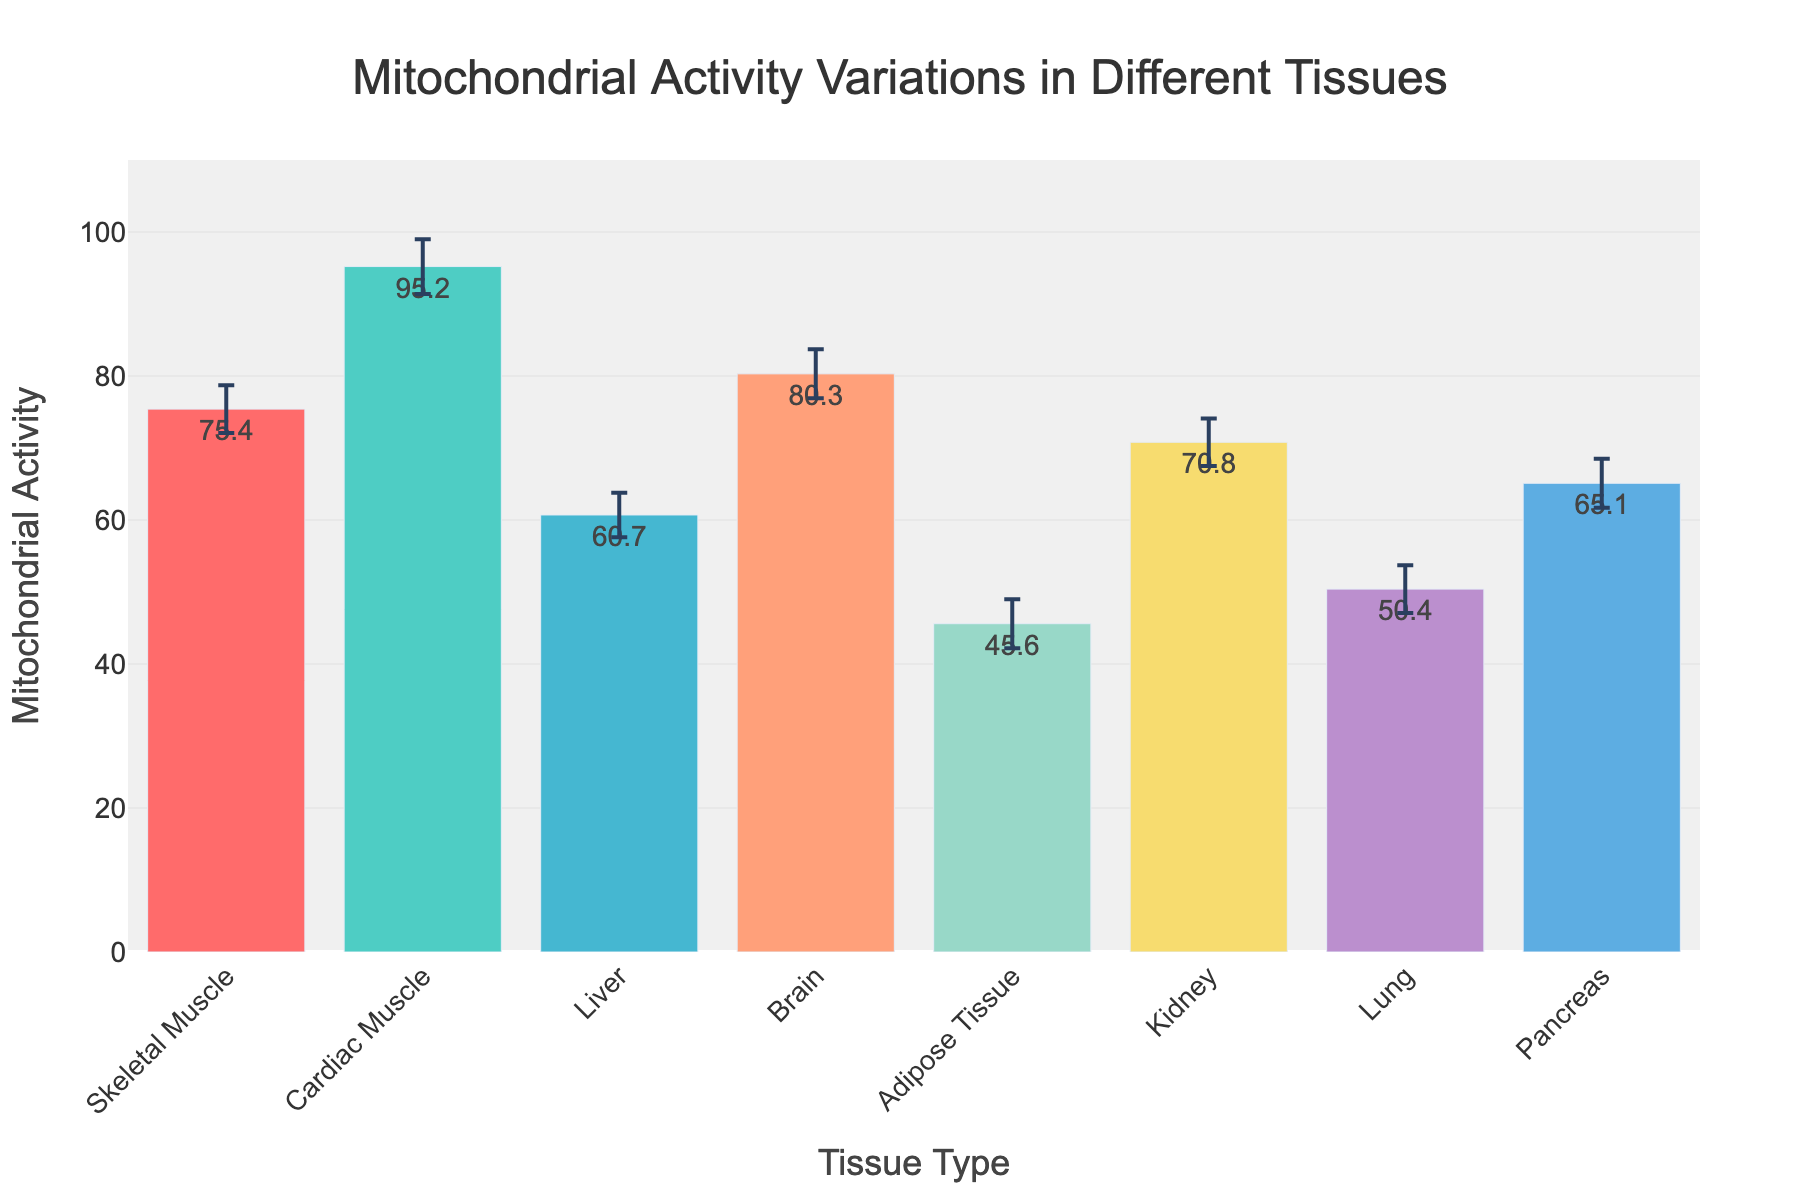what is the tissue type with the highest mitochondrial activity? Look at the bar with the highest value on the y-axis. The highest bar represents Cardiac Muscle with a mitochondrial activity value of 95.2.
Answer: Cardiac Muscle What is the average mitochondrial activity across all tissues? Add all the mean mitochondrial activity values and then divide by the number of tissues. (75.4 + 95.2 + 60.7 + 80.3 + 45.6 + 70.8 + 50.4 + 65.1) / 8 equals 68.175
Answer: 68.175 Which tissue type shows the lowest average mitochondrial activity? Look at the bar with the lowest value on the y-axis. The lowest bar represents Adipose Tissue with a value of 45.6.
Answer: Adipose Tissue Which tissues have mitochondrial activity values greater than 70? Identify bars with values higher than 70 on the y-axis. These bars correspond to Skeletal Muscle, Cardiac Muscle, Brain, and Kidney.
Answer: Skeletal Muscle, Cardiac Muscle, Brain, Kidney How much higher is the mitochondrial activity of the Brain compared to the Liver? Subtract the mean mitochondrial activity of the Liver from that of the Brain. 80.3 - 60.7 = 19.6
Answer: 19.6 What is the range of mitochondrial activity values for Skeletal Muscle considering the confidence intervals? Subtract the lower confidence interval from the upper confidence interval for Skeletal Muscle. 78.7 - 72.1 = 6.6
Answer: 6.6 Which tissue has the widest confidence interval for mitochondrial activity? Compare the range of confidence intervals for each tissue. Cardiac Muscle has the widest with (99.0 - 91.4 = 7.6).
Answer: Cardiac Muscle Compare the mitochondrial activity of the Lung and the Pancreas. Which one is higher? Look at the heights of the bars for Lung and Pancreas. Pancreas has a higher value (65.1) compared to Lung (50.4).
Answer: Pancreas Considering the confidence intervals, which tissue's mitochondrial activity might overlap with Brain’s activity? Check the confidence intervals of other tissues to see if any ranges overlap with the Brain’s CI [76.9, 83.7]. Skeletal Muscle [72.1, 78.7] overlaps with Brain’s lower CI range, indicating potential overlap.
Answer: Skeletal Muscle What is the difference between the highest and lowest mitochondrial activities observed? Subtract the lowest mean mitochondrial activity value from the highest. 95.2 (Cardiac Muscle) - 45.6 (Adipose Tissue) = 49.6
Answer: 49.6 